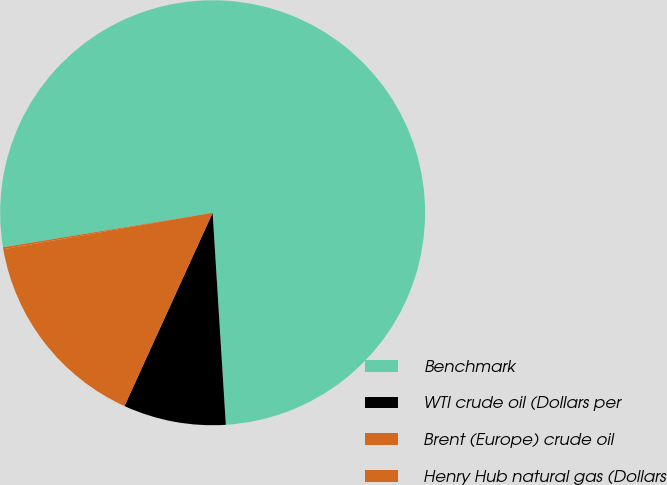<chart> <loc_0><loc_0><loc_500><loc_500><pie_chart><fcel>Benchmark<fcel>WTI crude oil (Dollars per<fcel>Brent (Europe) crude oil<fcel>Henry Hub natural gas (Dollars<nl><fcel>76.6%<fcel>7.8%<fcel>15.44%<fcel>0.15%<nl></chart> 